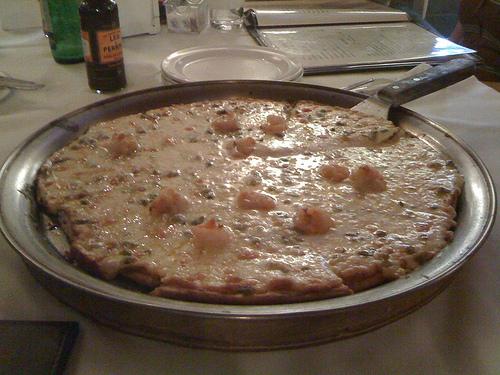Is this pizza being made in a restaurant?
Write a very short answer. Yes. Is that pizza?
Answer briefly. Yes. What is on the pizza?
Answer briefly. Cheese. What color is the serving platter?
Keep it brief. Silver. Where is this dish currently located?
Be succinct. Table. 